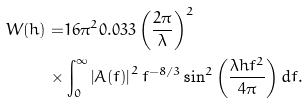Convert formula to latex. <formula><loc_0><loc_0><loc_500><loc_500>W ( h ) = & 1 6 \pi ^ { 2 } 0 . 0 3 3 \left ( \frac { 2 \pi } { \lambda } \right ) ^ { 2 } \\ \times & \int _ { 0 } ^ { \infty } \left | A ( f ) \right | ^ { 2 } f ^ { - 8 / 3 } \sin ^ { 2 } \left ( \frac { \lambda h f ^ { 2 } } { 4 \pi } \right ) d f .</formula> 